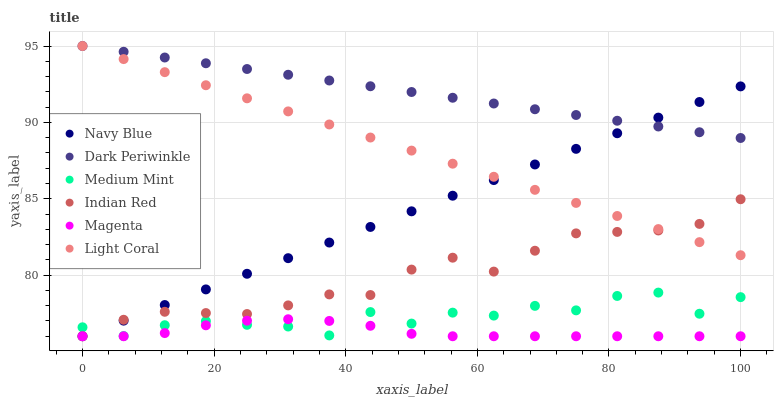Does Magenta have the minimum area under the curve?
Answer yes or no. Yes. Does Dark Periwinkle have the maximum area under the curve?
Answer yes or no. Yes. Does Navy Blue have the minimum area under the curve?
Answer yes or no. No. Does Navy Blue have the maximum area under the curve?
Answer yes or no. No. Is Dark Periwinkle the smoothest?
Answer yes or no. Yes. Is Medium Mint the roughest?
Answer yes or no. Yes. Is Navy Blue the smoothest?
Answer yes or no. No. Is Navy Blue the roughest?
Answer yes or no. No. Does Navy Blue have the lowest value?
Answer yes or no. Yes. Does Light Coral have the lowest value?
Answer yes or no. No. Does Dark Periwinkle have the highest value?
Answer yes or no. Yes. Does Navy Blue have the highest value?
Answer yes or no. No. Is Magenta less than Light Coral?
Answer yes or no. Yes. Is Dark Periwinkle greater than Medium Mint?
Answer yes or no. Yes. Does Indian Red intersect Light Coral?
Answer yes or no. Yes. Is Indian Red less than Light Coral?
Answer yes or no. No. Is Indian Red greater than Light Coral?
Answer yes or no. No. Does Magenta intersect Light Coral?
Answer yes or no. No. 